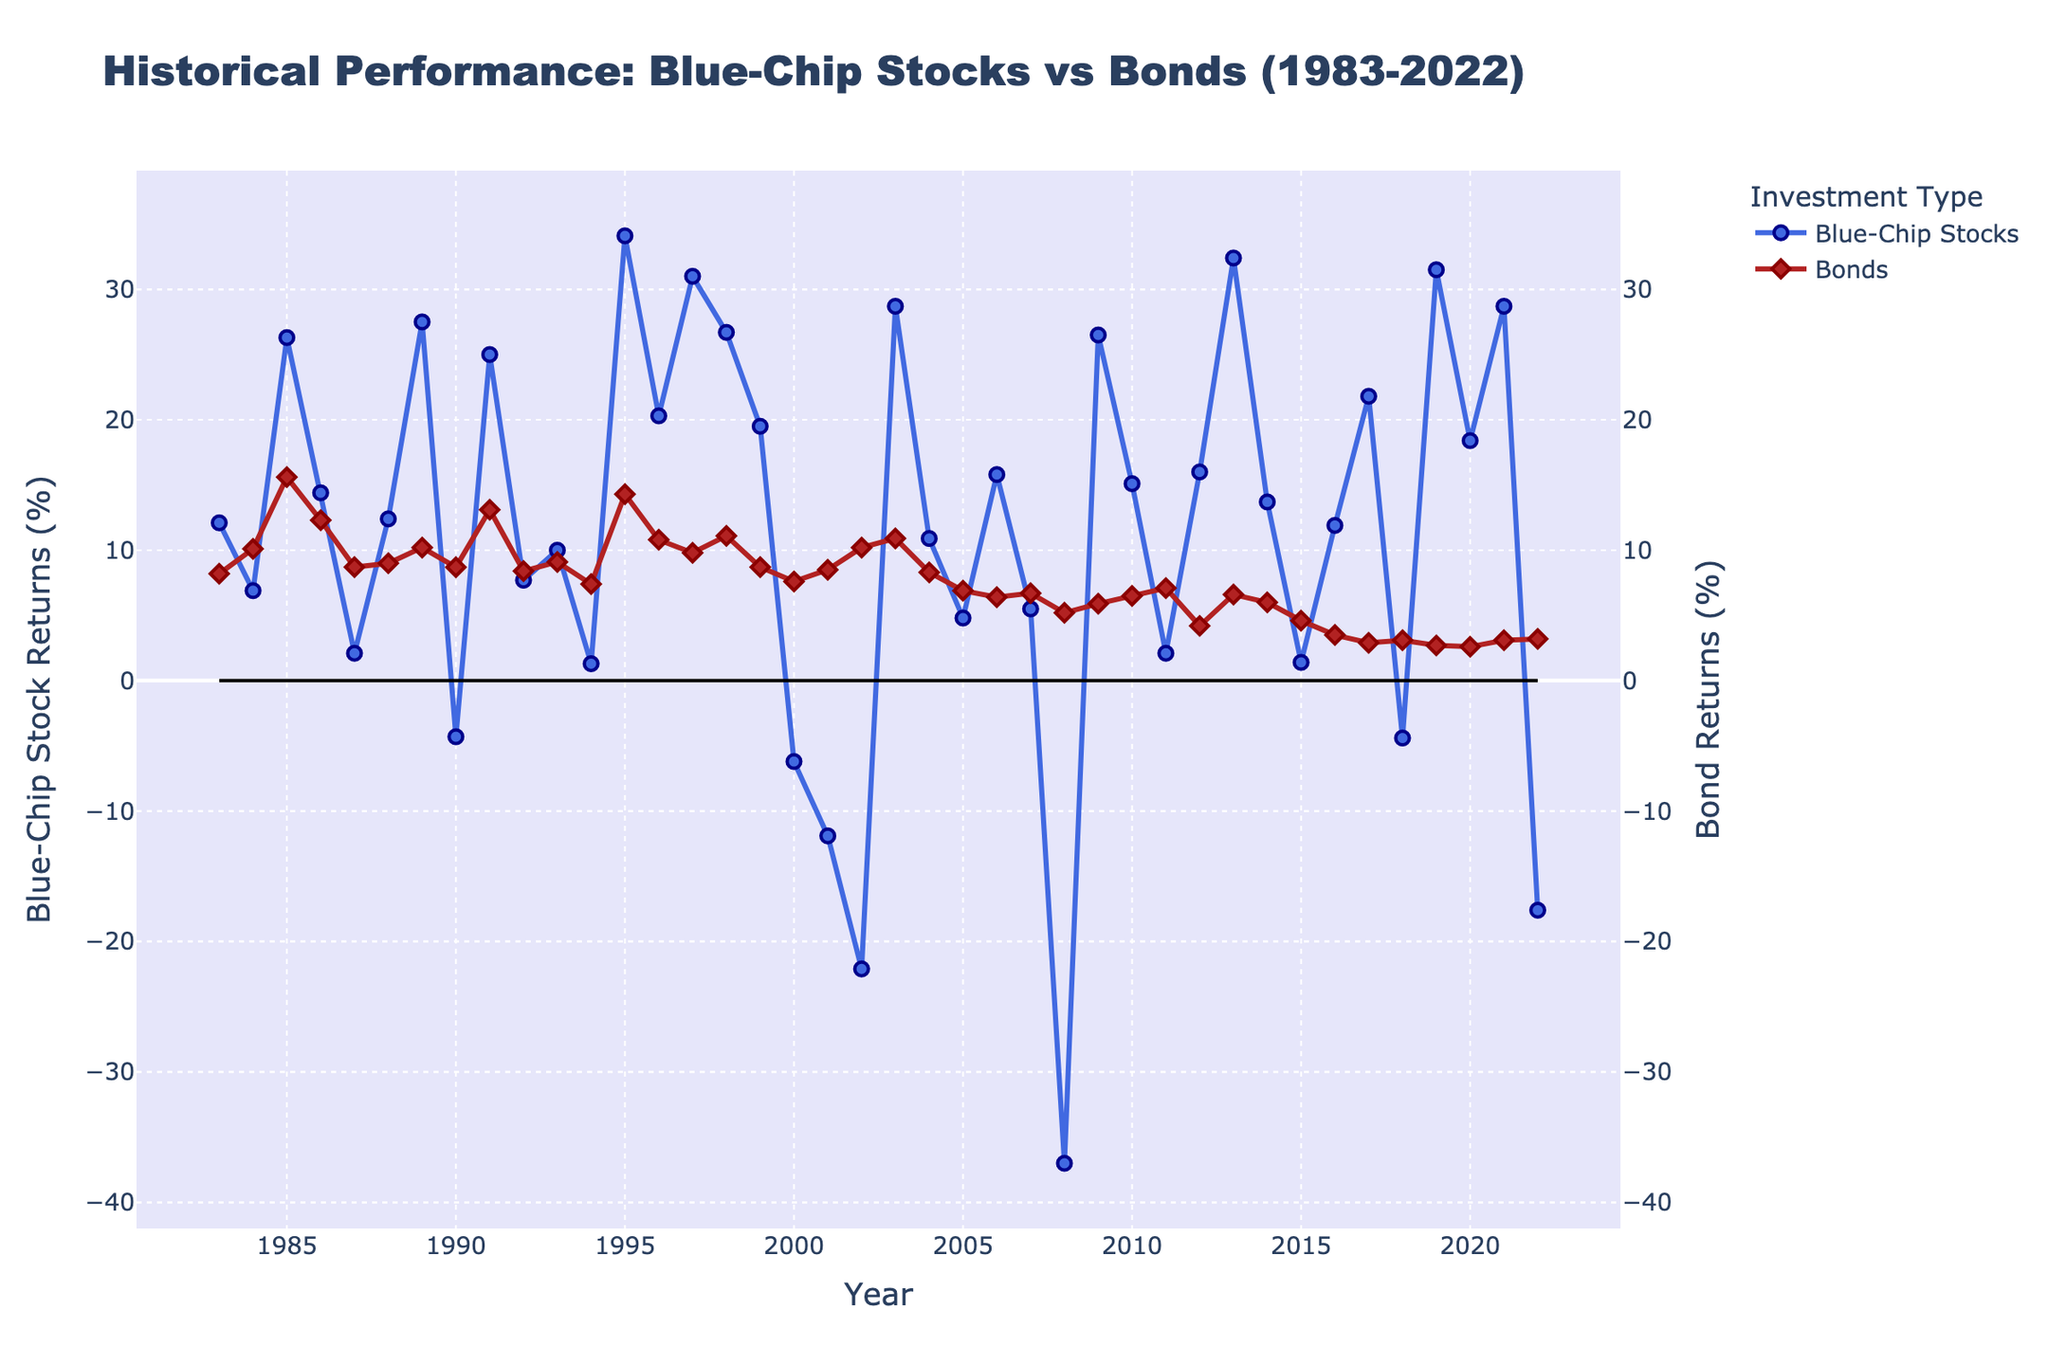What are the titles of both Y-axes? The title of the left Y-axis is "Blue-Chip Stock Returns (%)", while the title of the right Y-axis is "Bond Returns (%)". These titles help in identifying the performance metrics of blue-chip stocks and bonds.
Answer: Blue-Chip Stock Returns (%) and Bond Returns (%) What are the highest return percentages for blue-chip stocks and bonds over the 40-year period? The highest return percentage for blue-chip stocks is around 37.0% (2008), and for bonds, it is around 15.6% (1985). This information can be seen by locating the peak points on each respective Y-axis.
Answer: 37.0% and 15.6% How many years did blue-chip stocks experience negative returns? To find the number of years with negative returns for blue-chip stocks, count the instances where the blue line dips below 0 on the Y-axis. These years are 1990, 2000, 2001, 2002, 2008, 2018, and 2022, making it seven in total.
Answer: 7 years In which year did bonds outperform blue-chip stocks by the largest margin? Calculate the difference between bond and blue-chip stock returns for each year. The year 2008 shows the largest margin, with bonds at 5.2% and blue-chip stocks at -37.0%, giving a difference of 42.2%.
Answer: 2008 What years show a decline in both blue-chip stock and bond returns? Identify years where both lines indicate a drop from the previous year's data. The years are 1984, 1987, 1990, 1994, 2000, 2001, 2002, 2005, 2007, 2008, 2011, 2015, 2018, and 2022. There are 14 years in total.
Answer: 14 years Which investment type had more consistent returns over the 40 years? Consistency refers to less fluctuation. Observing both lines, the bond returns (red) show less variability and are more stable compared to the blue-chip stock returns (blue), which have higher peaks and valleys.
Answer: Bonds What is the average return for blue-chip stocks and bonds during economic recessions (e.g., 2008)? Specifically looking at the years of economic recessions (2008), blue-chip stocks had a return of -37.0% and bonds had a return of 5.2%. The average return for blue-chip stocks is -37.0%, and for bonds is 5.2%.
Answer: -37.0% for blue-chip stocks, 5.2% for bonds Are there years where both blue-chip stocks and bonds have their returns above 10%? To find such years, check when both lines cross the 10% mark on the Y-axis. These years are 1985, 1989, 1991, 1995, 1996, 1997, 1998, and 2003.
Answer: 8 years 